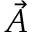Convert formula to latex. <formula><loc_0><loc_0><loc_500><loc_500>\vec { A }</formula> 